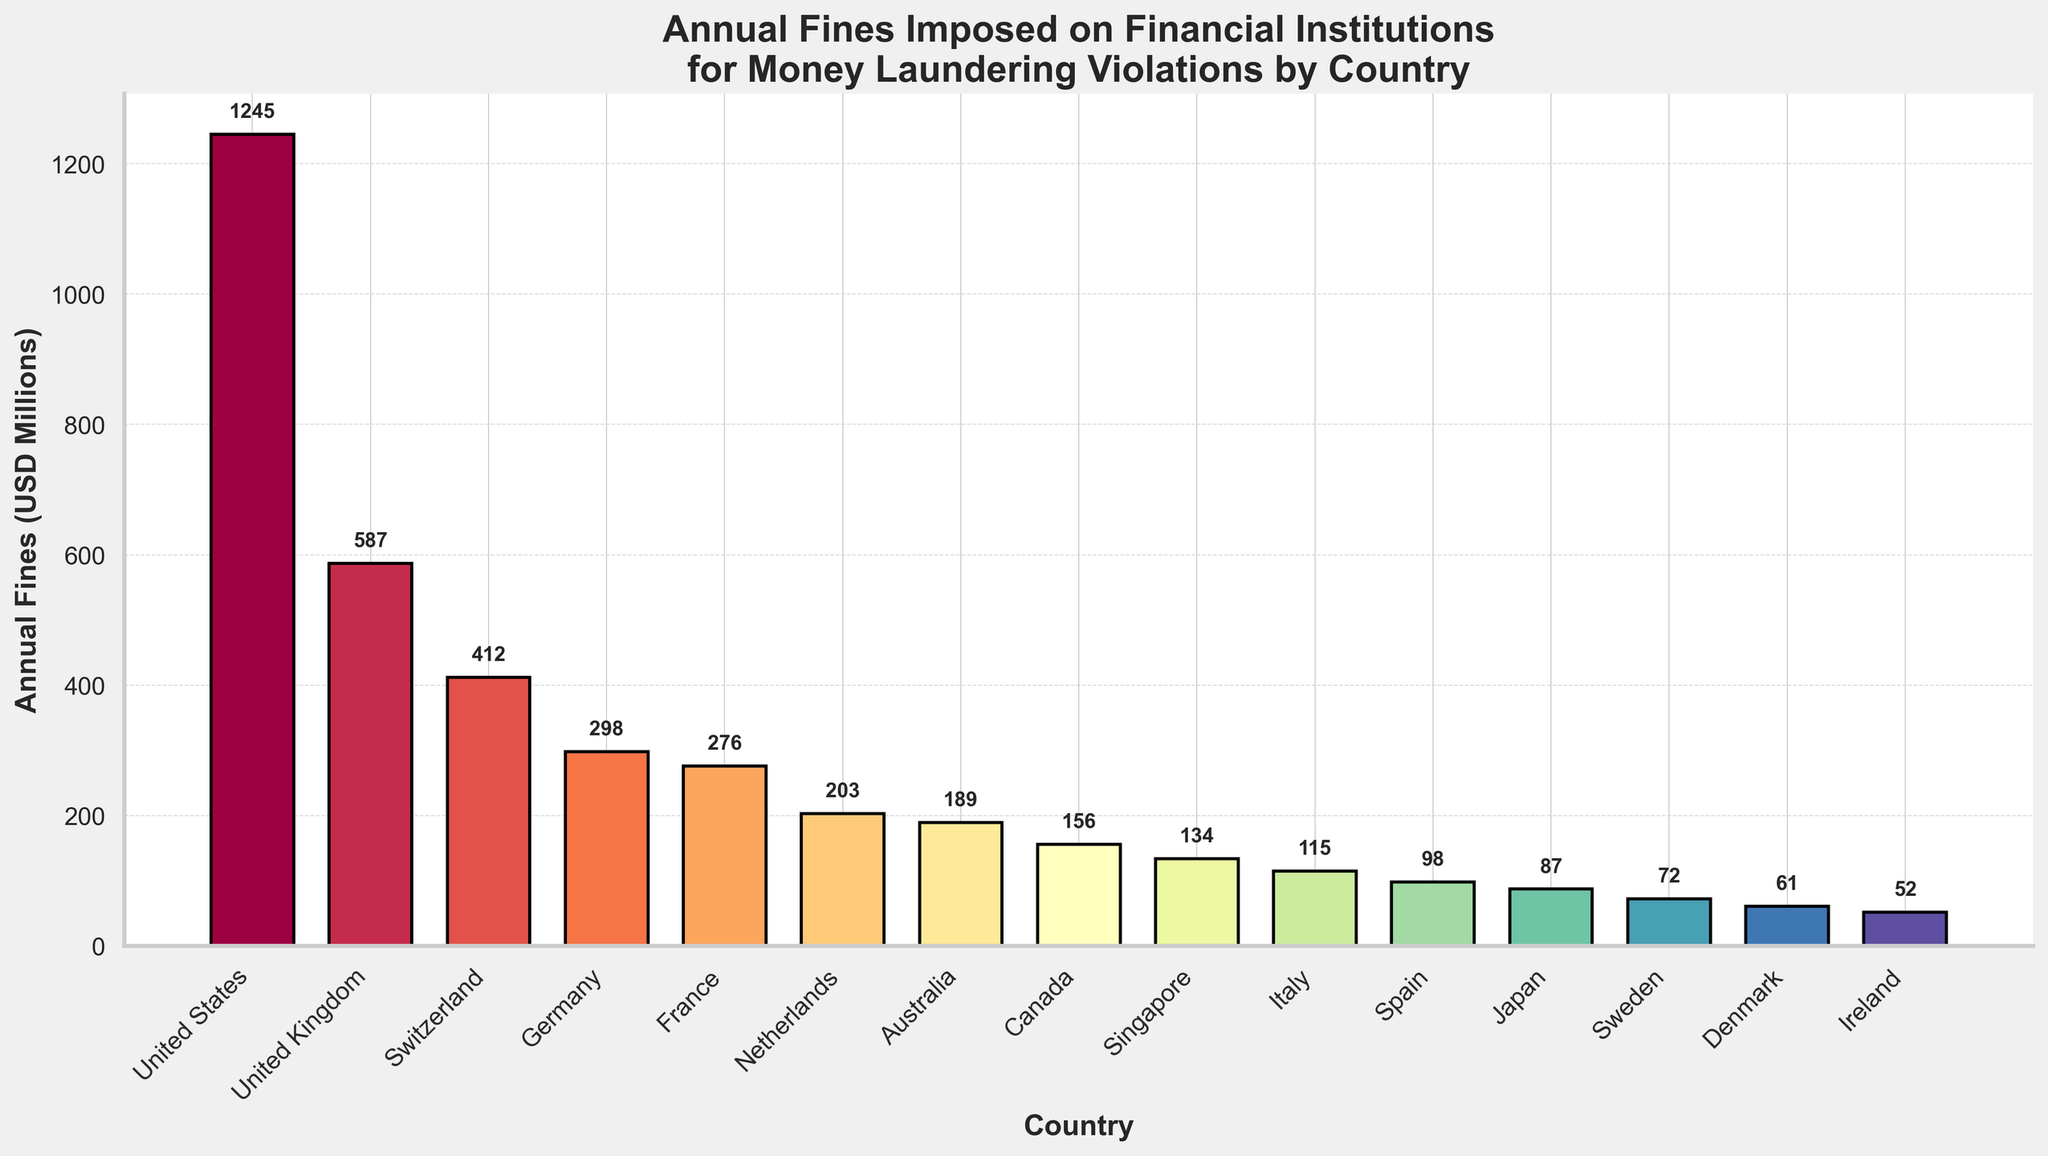Which country has the highest annual fines for money laundering violations? The highest bar on the chart represents the country with the highest fines. It is colored prominently and labeled with the highest numerical value.
Answer: United States What is the total amount of annual fines for all countries? Sum the values of the annual fines for each country: 1245 + 587 + 412 + 298 + 276 + 203 + 189 + 156 + 134 + 115 + 98 + 87 + 72 + 61 + 52 = 3985 million USD.
Answer: 3985 How much more are the annual fines imposed on financial institutions in the United States compared to the United Kingdom? The fines for the United States are 1245 million USD and for the United Kingdom are 587 million USD. Subtract 587 from 1245: 1245 - 587 = 658 million USD.
Answer: 658 Which countries have annual fines that are lower than 100 million USD? Identify the bars in the chart that are shorter than the 100 million USD mark on the y-axis. These are Japan (87), Sweden (72), Denmark (61), and Ireland (52).
Answer: Japan, Sweden, Denmark, Ireland What is the average amount of annual fines among the top three countries? Identify the top three countries by the height of their bars: United States (1245), United Kingdom (587), and Switzerland (412). Sum these values and divide by three: (1245 + 587 + 412) / 3 = 748 million USD.
Answer: 748 Which country has the smallest annual fines, and what is the amount? The shortest bar on the chart corresponds to the country with the smallest annual fines, which is Ireland with 52 million USD.
Answer: Ireland, 52 How do the annual fines of France compare to those of Germany? The chart shows that France has an annual fine of 276 million USD, and Germany has 298 million USD. Thus, Germany’s fines are slightly higher than those of France.
Answer: Germany's are higher What is the median annual fine amount for all the countries? List all fines in ascending order: 52, 61, 72, 87, 98, 115, 134, 156, 189, 203, 276, 298, 412, 587, 1245. The median is the middle value, which is the 8th value in this 15-country list: 156 million USD.
Answer: 156 How many countries have annual fines greater than 500 million USD? Identify the bars that extend higher than the 500 million USD mark. These countries are United States (1245) and United Kingdom (587). Therefore, there are 2 countries.
Answer: 2 What is the combined total of annual fines from the three countries with the lowest annual fines? Identify the three countries with the shortest bars: Ireland (52), Denmark (61), and Sweden (72). Sum these values: 52 + 61 + 72 = 185 million USD.
Answer: 185 